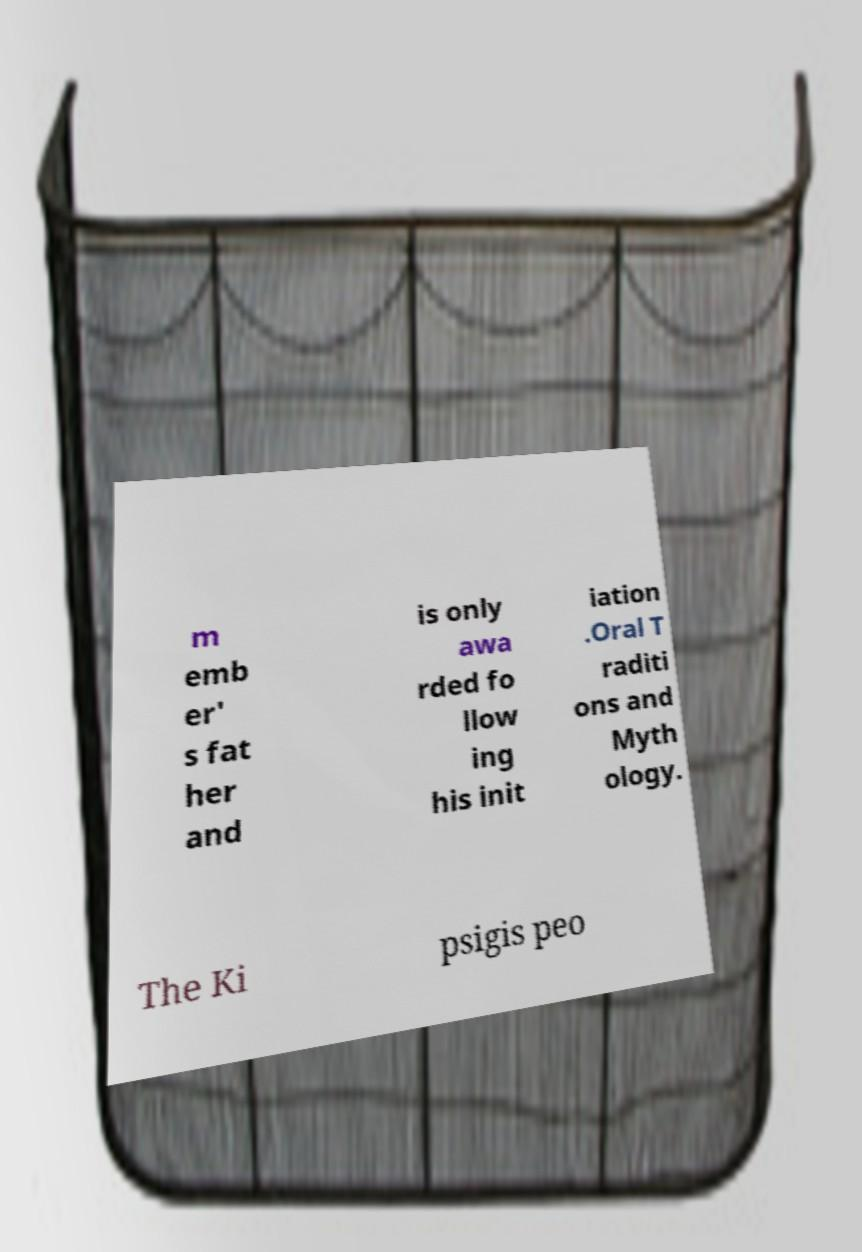Could you extract and type out the text from this image? m emb er' s fat her and is only awa rded fo llow ing his init iation .Oral T raditi ons and Myth ology. The Ki psigis peo 